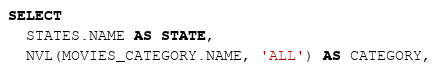<code> <loc_0><loc_0><loc_500><loc_500><_SQL_>SELECT
  STATES.NAME AS STATE,
  NVL(MOVIES_CATEGORY.NAME, 'ALL') AS CATEGORY,</code> 